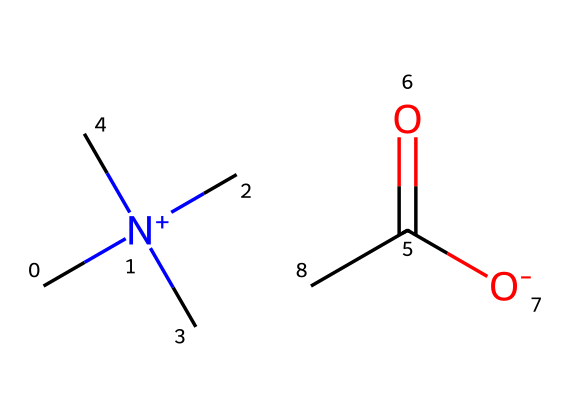what is the molecular formula of this ionic liquid? By analyzing the SMILES representation, we can count the number of each type of atom present. The molecule consists of carbon (C), nitrogen (N), and oxygen (O) atoms. Counting these, we find 6 carbons, 1 nitrogen, and 2 oxygens. The molecular formula can be represented as C6H12N1O2.
Answer: C6H12N1O2 how many functional groups are present in the chemical? Looking at the structure implied by the SMILES notation, we identify the presence of a carboxyl group (C(=O)([O-])) which is one functional group. There are no other distinct functional groups observed in the molecule. Therefore, there is 1 functional group present.
Answer: 1 what type of nitrogen atom is present in the ionic liquid? The nitrogen in this structure is positively charged and is bonded to three carbon atoms, indicating that it is a quaternary ammonium ion. This is a characteristic feature of ionic liquids where nitrogen is fully substituted.
Answer: quaternary ammonium how would the arrangement of this ionic liquid enhance water retention in soil? The ionic structure of this liquid allows it to interact strongly with water molecules, creating a gel-like consistency that helps retain moisture. The positive charge on the nitrogen might also interact with negatively charged soil particles, helping to bind water molecules in the soil. Hence, the arrangement contributes to improved water retention.
Answer: enhances water retention what is the predicted solubility of this ionic liquid in water? Ionic liquids generally have high solubility in water due to their ionic nature. The presence of the polar carboxylate group further enhances the solubility of this particular ionic liquid in aqueous environments.
Answer: high solubility in what context can this ionic liquid be used as a soil amendment? This ionic liquid can be used in arid farming regions to enhance water retention in soil, allowing crops to better withstand drought conditions and improve overall agricultural productivity.
Answer: arid farming 